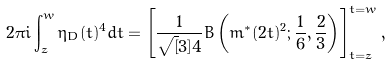Convert formula to latex. <formula><loc_0><loc_0><loc_500><loc_500>2 \pi i \int ^ { w } _ { z } \eta _ { D } ( t ) ^ { 4 } d t = \left [ \frac { 1 } { \sqrt { [ } 3 ] { 4 } } B \left ( m ^ { * } ( 2 t ) ^ { 2 } ; \frac { 1 } { 6 } , \frac { 2 } { 3 } \right ) \right ] ^ { t = w } _ { t = z } ,</formula> 